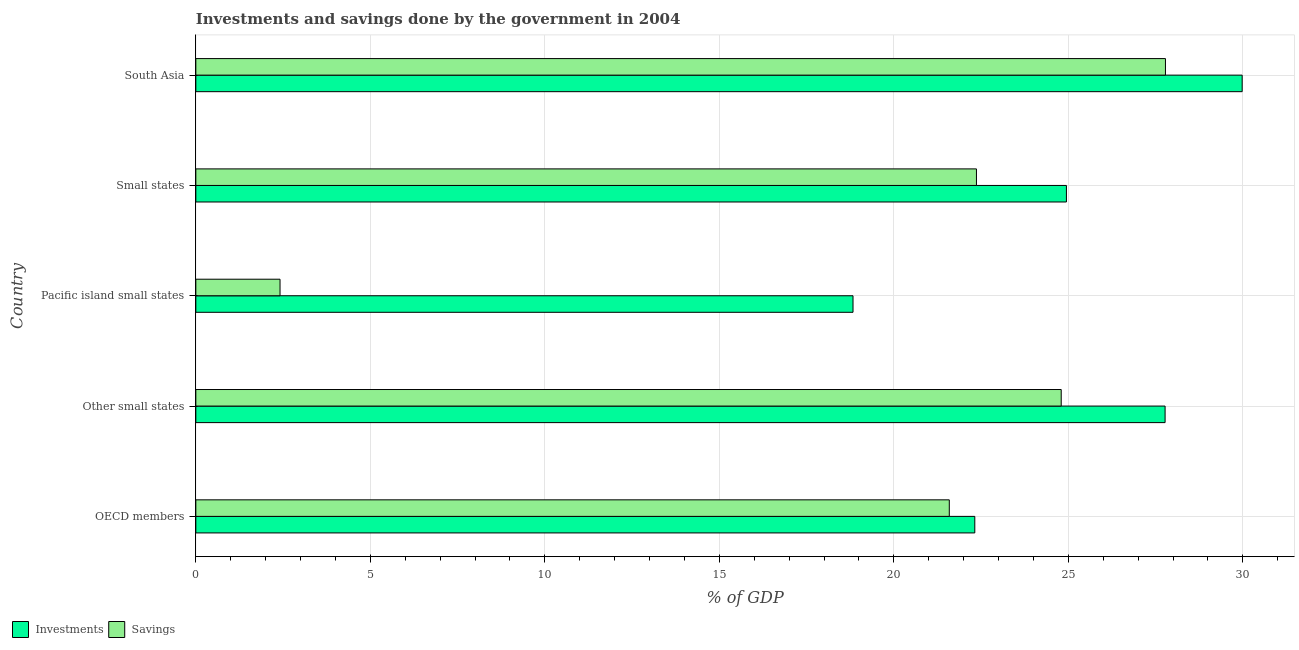How many different coloured bars are there?
Ensure brevity in your answer.  2. How many bars are there on the 4th tick from the bottom?
Provide a succinct answer. 2. What is the label of the 3rd group of bars from the top?
Give a very brief answer. Pacific island small states. In how many cases, is the number of bars for a given country not equal to the number of legend labels?
Make the answer very short. 0. What is the savings of government in Small states?
Provide a succinct answer. 22.37. Across all countries, what is the maximum investments of government?
Provide a succinct answer. 29.98. Across all countries, what is the minimum savings of government?
Your answer should be compact. 2.41. In which country was the savings of government minimum?
Give a very brief answer. Pacific island small states. What is the total investments of government in the graph?
Offer a very short reply. 123.84. What is the difference between the investments of government in OECD members and that in South Asia?
Provide a short and direct response. -7.66. What is the difference between the savings of government in Pacific island small states and the investments of government in Small states?
Offer a terse response. -22.53. What is the average investments of government per country?
Offer a terse response. 24.77. What is the difference between the savings of government and investments of government in Small states?
Make the answer very short. -2.58. What is the ratio of the investments of government in Other small states to that in Small states?
Your response must be concise. 1.11. What is the difference between the highest and the second highest investments of government?
Ensure brevity in your answer.  2.21. What is the difference between the highest and the lowest savings of government?
Make the answer very short. 25.37. In how many countries, is the investments of government greater than the average investments of government taken over all countries?
Your response must be concise. 3. What does the 2nd bar from the top in Pacific island small states represents?
Provide a short and direct response. Investments. What does the 2nd bar from the bottom in Other small states represents?
Ensure brevity in your answer.  Savings. How many bars are there?
Your response must be concise. 10. How many countries are there in the graph?
Your response must be concise. 5. Are the values on the major ticks of X-axis written in scientific E-notation?
Provide a succinct answer. No. Does the graph contain any zero values?
Ensure brevity in your answer.  No. Does the graph contain grids?
Ensure brevity in your answer.  Yes. Where does the legend appear in the graph?
Your response must be concise. Bottom left. How many legend labels are there?
Provide a short and direct response. 2. What is the title of the graph?
Your answer should be very brief. Investments and savings done by the government in 2004. What is the label or title of the X-axis?
Your response must be concise. % of GDP. What is the label or title of the Y-axis?
Offer a terse response. Country. What is the % of GDP of Investments in OECD members?
Provide a succinct answer. 22.32. What is the % of GDP in Savings in OECD members?
Your answer should be very brief. 21.59. What is the % of GDP in Investments in Other small states?
Offer a very short reply. 27.77. What is the % of GDP in Savings in Other small states?
Your answer should be compact. 24.79. What is the % of GDP in Investments in Pacific island small states?
Give a very brief answer. 18.83. What is the % of GDP in Savings in Pacific island small states?
Keep it short and to the point. 2.41. What is the % of GDP in Investments in Small states?
Your response must be concise. 24.94. What is the % of GDP of Savings in Small states?
Give a very brief answer. 22.37. What is the % of GDP of Investments in South Asia?
Ensure brevity in your answer.  29.98. What is the % of GDP of Savings in South Asia?
Your answer should be compact. 27.78. Across all countries, what is the maximum % of GDP of Investments?
Your response must be concise. 29.98. Across all countries, what is the maximum % of GDP in Savings?
Provide a short and direct response. 27.78. Across all countries, what is the minimum % of GDP of Investments?
Provide a succinct answer. 18.83. Across all countries, what is the minimum % of GDP of Savings?
Provide a short and direct response. 2.41. What is the total % of GDP of Investments in the graph?
Provide a succinct answer. 123.84. What is the total % of GDP in Savings in the graph?
Your response must be concise. 98.94. What is the difference between the % of GDP in Investments in OECD members and that in Other small states?
Your answer should be compact. -5.45. What is the difference between the % of GDP of Savings in OECD members and that in Other small states?
Provide a succinct answer. -3.21. What is the difference between the % of GDP of Investments in OECD members and that in Pacific island small states?
Offer a very short reply. 3.49. What is the difference between the % of GDP of Savings in OECD members and that in Pacific island small states?
Keep it short and to the point. 19.18. What is the difference between the % of GDP of Investments in OECD members and that in Small states?
Your answer should be very brief. -2.63. What is the difference between the % of GDP in Savings in OECD members and that in Small states?
Your answer should be compact. -0.78. What is the difference between the % of GDP of Investments in OECD members and that in South Asia?
Provide a short and direct response. -7.66. What is the difference between the % of GDP of Savings in OECD members and that in South Asia?
Provide a short and direct response. -6.19. What is the difference between the % of GDP of Investments in Other small states and that in Pacific island small states?
Keep it short and to the point. 8.94. What is the difference between the % of GDP in Savings in Other small states and that in Pacific island small states?
Give a very brief answer. 22.38. What is the difference between the % of GDP of Investments in Other small states and that in Small states?
Provide a short and direct response. 2.83. What is the difference between the % of GDP of Savings in Other small states and that in Small states?
Provide a succinct answer. 2.43. What is the difference between the % of GDP of Investments in Other small states and that in South Asia?
Your response must be concise. -2.21. What is the difference between the % of GDP of Savings in Other small states and that in South Asia?
Offer a terse response. -2.99. What is the difference between the % of GDP in Investments in Pacific island small states and that in Small states?
Your answer should be very brief. -6.11. What is the difference between the % of GDP in Savings in Pacific island small states and that in Small states?
Your answer should be compact. -19.95. What is the difference between the % of GDP in Investments in Pacific island small states and that in South Asia?
Provide a short and direct response. -11.15. What is the difference between the % of GDP in Savings in Pacific island small states and that in South Asia?
Your answer should be compact. -25.37. What is the difference between the % of GDP of Investments in Small states and that in South Asia?
Your response must be concise. -5.04. What is the difference between the % of GDP in Savings in Small states and that in South Asia?
Your response must be concise. -5.42. What is the difference between the % of GDP in Investments in OECD members and the % of GDP in Savings in Other small states?
Give a very brief answer. -2.48. What is the difference between the % of GDP in Investments in OECD members and the % of GDP in Savings in Pacific island small states?
Make the answer very short. 19.91. What is the difference between the % of GDP in Investments in OECD members and the % of GDP in Savings in Small states?
Offer a terse response. -0.05. What is the difference between the % of GDP in Investments in OECD members and the % of GDP in Savings in South Asia?
Offer a terse response. -5.46. What is the difference between the % of GDP of Investments in Other small states and the % of GDP of Savings in Pacific island small states?
Your answer should be very brief. 25.36. What is the difference between the % of GDP of Investments in Other small states and the % of GDP of Savings in Small states?
Keep it short and to the point. 5.4. What is the difference between the % of GDP in Investments in Other small states and the % of GDP in Savings in South Asia?
Your response must be concise. -0.01. What is the difference between the % of GDP in Investments in Pacific island small states and the % of GDP in Savings in Small states?
Keep it short and to the point. -3.54. What is the difference between the % of GDP of Investments in Pacific island small states and the % of GDP of Savings in South Asia?
Offer a very short reply. -8.95. What is the difference between the % of GDP of Investments in Small states and the % of GDP of Savings in South Asia?
Your answer should be very brief. -2.84. What is the average % of GDP in Investments per country?
Offer a terse response. 24.77. What is the average % of GDP in Savings per country?
Provide a short and direct response. 19.79. What is the difference between the % of GDP in Investments and % of GDP in Savings in OECD members?
Make the answer very short. 0.73. What is the difference between the % of GDP in Investments and % of GDP in Savings in Other small states?
Your answer should be compact. 2.98. What is the difference between the % of GDP of Investments and % of GDP of Savings in Pacific island small states?
Ensure brevity in your answer.  16.42. What is the difference between the % of GDP in Investments and % of GDP in Savings in Small states?
Make the answer very short. 2.58. What is the difference between the % of GDP of Investments and % of GDP of Savings in South Asia?
Offer a very short reply. 2.2. What is the ratio of the % of GDP of Investments in OECD members to that in Other small states?
Provide a succinct answer. 0.8. What is the ratio of the % of GDP of Savings in OECD members to that in Other small states?
Make the answer very short. 0.87. What is the ratio of the % of GDP of Investments in OECD members to that in Pacific island small states?
Offer a terse response. 1.19. What is the ratio of the % of GDP of Savings in OECD members to that in Pacific island small states?
Offer a terse response. 8.95. What is the ratio of the % of GDP in Investments in OECD members to that in Small states?
Your answer should be very brief. 0.89. What is the ratio of the % of GDP in Savings in OECD members to that in Small states?
Provide a short and direct response. 0.97. What is the ratio of the % of GDP of Investments in OECD members to that in South Asia?
Give a very brief answer. 0.74. What is the ratio of the % of GDP of Savings in OECD members to that in South Asia?
Your answer should be very brief. 0.78. What is the ratio of the % of GDP in Investments in Other small states to that in Pacific island small states?
Offer a terse response. 1.47. What is the ratio of the % of GDP in Savings in Other small states to that in Pacific island small states?
Offer a very short reply. 10.28. What is the ratio of the % of GDP in Investments in Other small states to that in Small states?
Your response must be concise. 1.11. What is the ratio of the % of GDP in Savings in Other small states to that in Small states?
Provide a succinct answer. 1.11. What is the ratio of the % of GDP of Investments in Other small states to that in South Asia?
Offer a terse response. 0.93. What is the ratio of the % of GDP of Savings in Other small states to that in South Asia?
Make the answer very short. 0.89. What is the ratio of the % of GDP in Investments in Pacific island small states to that in Small states?
Offer a terse response. 0.75. What is the ratio of the % of GDP of Savings in Pacific island small states to that in Small states?
Your answer should be very brief. 0.11. What is the ratio of the % of GDP of Investments in Pacific island small states to that in South Asia?
Offer a terse response. 0.63. What is the ratio of the % of GDP in Savings in Pacific island small states to that in South Asia?
Give a very brief answer. 0.09. What is the ratio of the % of GDP in Investments in Small states to that in South Asia?
Give a very brief answer. 0.83. What is the ratio of the % of GDP in Savings in Small states to that in South Asia?
Offer a terse response. 0.81. What is the difference between the highest and the second highest % of GDP in Investments?
Offer a terse response. 2.21. What is the difference between the highest and the second highest % of GDP in Savings?
Offer a very short reply. 2.99. What is the difference between the highest and the lowest % of GDP of Investments?
Provide a succinct answer. 11.15. What is the difference between the highest and the lowest % of GDP of Savings?
Keep it short and to the point. 25.37. 